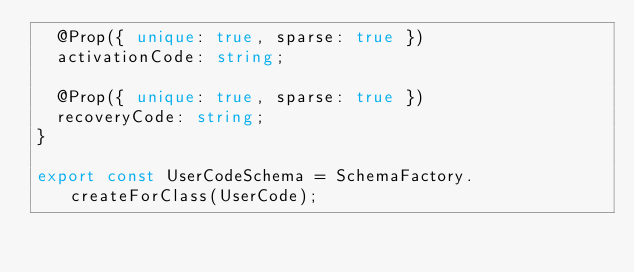Convert code to text. <code><loc_0><loc_0><loc_500><loc_500><_TypeScript_>  @Prop({ unique: true, sparse: true })
  activationCode: string;

  @Prop({ unique: true, sparse: true })
  recoveryCode: string;
}

export const UserCodeSchema = SchemaFactory.createForClass(UserCode);
</code> 